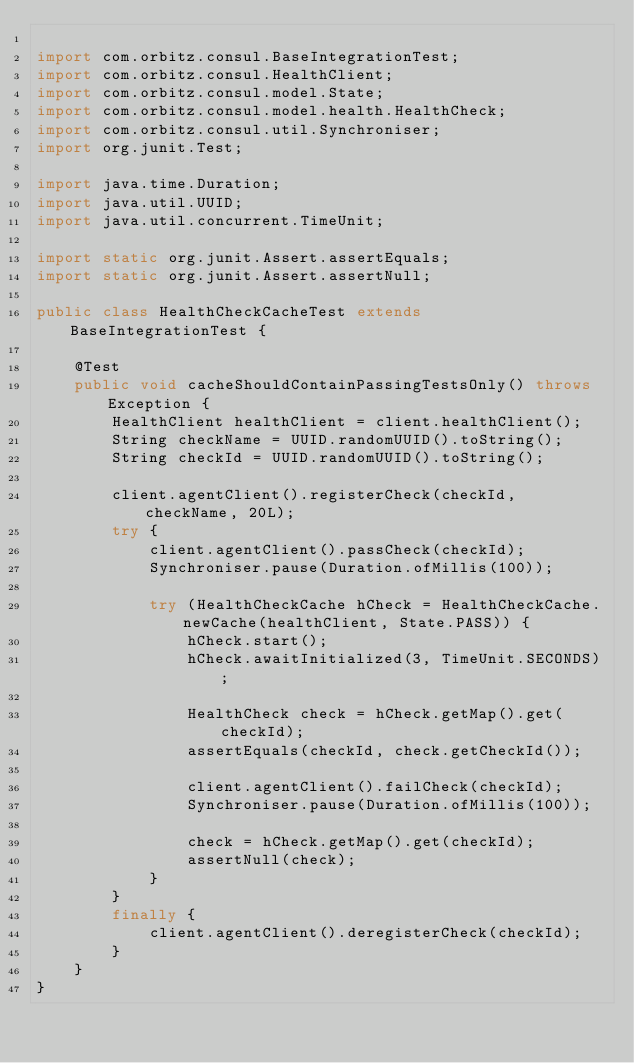Convert code to text. <code><loc_0><loc_0><loc_500><loc_500><_Java_>
import com.orbitz.consul.BaseIntegrationTest;
import com.orbitz.consul.HealthClient;
import com.orbitz.consul.model.State;
import com.orbitz.consul.model.health.HealthCheck;
import com.orbitz.consul.util.Synchroniser;
import org.junit.Test;

import java.time.Duration;
import java.util.UUID;
import java.util.concurrent.TimeUnit;

import static org.junit.Assert.assertEquals;
import static org.junit.Assert.assertNull;

public class HealthCheckCacheTest extends BaseIntegrationTest {

    @Test
    public void cacheShouldContainPassingTestsOnly() throws Exception {
        HealthClient healthClient = client.healthClient();
        String checkName = UUID.randomUUID().toString();
        String checkId = UUID.randomUUID().toString();

        client.agentClient().registerCheck(checkId, checkName, 20L);
        try {
            client.agentClient().passCheck(checkId);
            Synchroniser.pause(Duration.ofMillis(100));

            try (HealthCheckCache hCheck = HealthCheckCache.newCache(healthClient, State.PASS)) {
                hCheck.start();
                hCheck.awaitInitialized(3, TimeUnit.SECONDS);

                HealthCheck check = hCheck.getMap().get(checkId);
                assertEquals(checkId, check.getCheckId());

                client.agentClient().failCheck(checkId);
                Synchroniser.pause(Duration.ofMillis(100));

                check = hCheck.getMap().get(checkId);
                assertNull(check);
            }
        }
        finally {
            client.agentClient().deregisterCheck(checkId);
        }
    }
}
</code> 